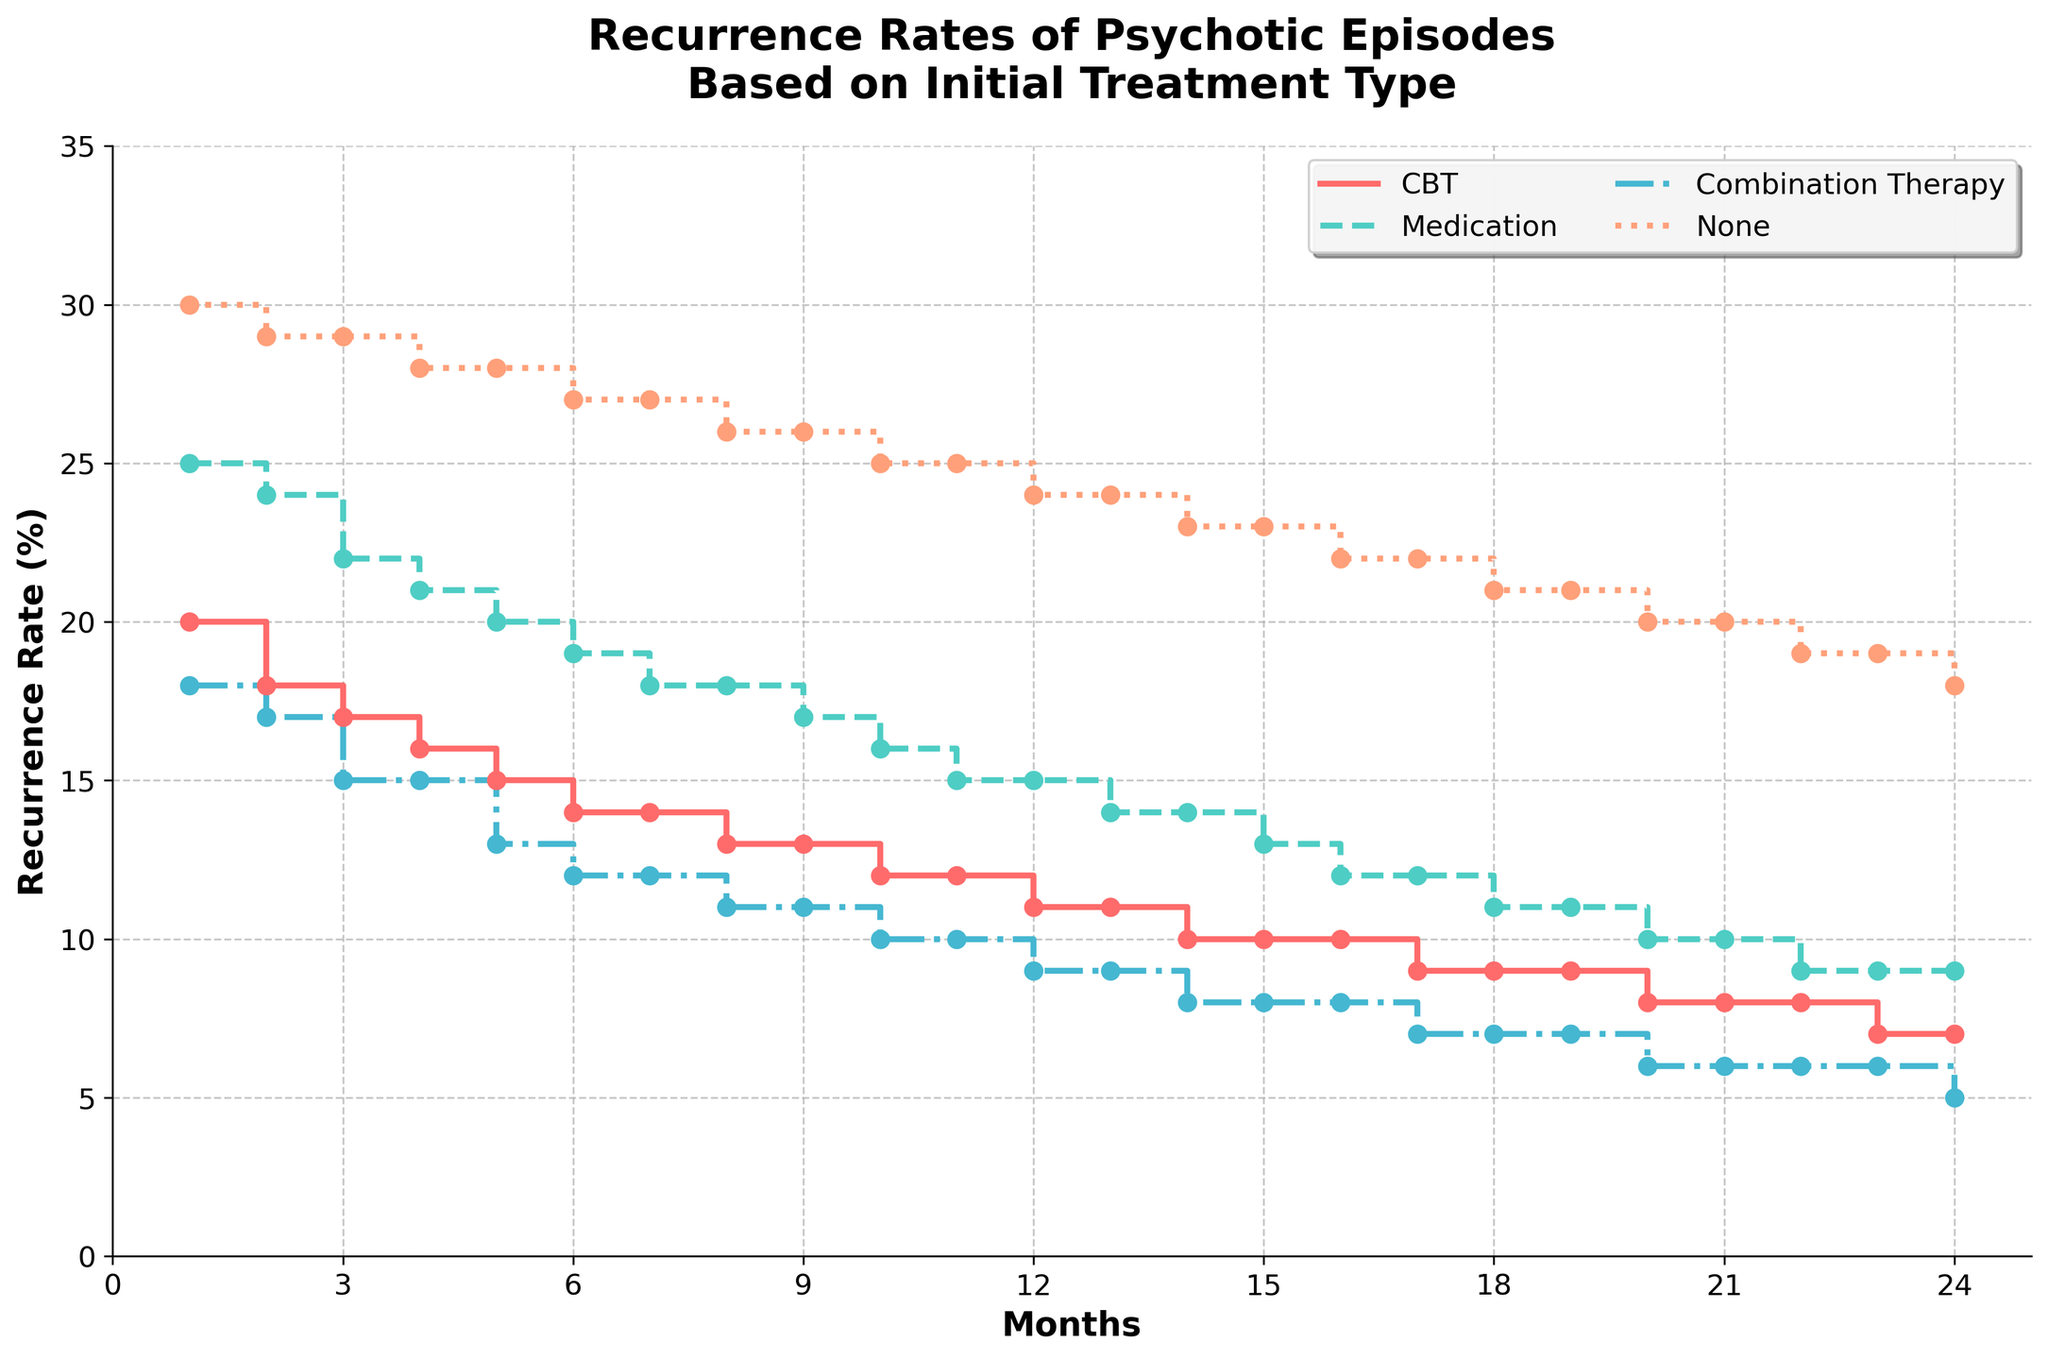What is the title of the figure? The title of the figure is displayed at the top and provides a summary of what the plot is about.
Answer: Recurrence Rates of Psychotic Episodes Based on Initial Treatment Type What is the recurrence rate of CBT at Month 6? Look at the intersection of the 'CBT' curve and the vertical line at Month 6. The point where they intersect represents the recurrence rate.
Answer: 14% Which treatment type has the highest recurrence rate at Month 1? Compare the recurrence rates of all treatment types at Month 1 by looking at their respective values on the y-axis. The highest value indicates the treatment with the highest recurrence rate.
Answer: None How does the recurrence rate for Medication change from Month 5 to Month 10? Identify the recurrence rate for Medication at Month 5 and Month 10 from the plot. Calculate the difference by subtracting the latter from the former.
Answer: It decreases from 20% to 16%, a change of -4% Which treatment type consistently shows the lowest recurrence rate? Observe the trend lines for all treatment types and compare them across all months. The treatment with the lowest values consistently across the months achieves this.
Answer: Combination Therapy From Month 12 to Month 24, what is the total decrease in recurrence rate for the group receiving no treatment? Find the recurrence rate for the None group at Month 12 and Month 24. Subtract the Month 24 value from the Month 12 value.
Answer: From 24% to 18%, a total decrease of 6% Between which months does CBT show no change in recurrence rate? Identify periods where there is no vertical step change in the CBT curve. These flat sections indicate no change.
Answer: Month 6 to Month 7 At what months do Combination Therapy and Medication show equal recurrence rates? Compare the points on the x-axis where the curves for Combination Therapy and Medication intersect each other. Determine those shared months.
Answer: Month 7 and Month 16 Which treatment shows a steady decline in recurrence rates but never drops to 0%? Analyze all treatments' trends, and identify which one consistently declines but doesn't reach the x-axis.
Answer: None 